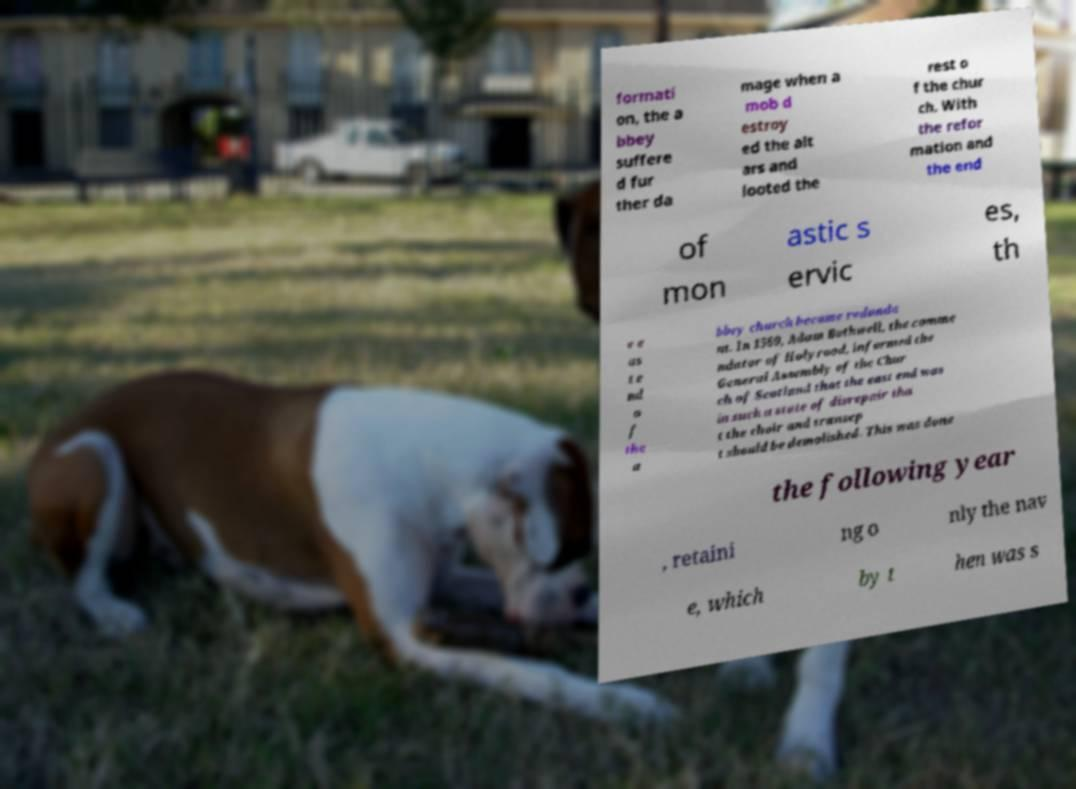Please read and relay the text visible in this image. What does it say? formati on, the a bbey suffere d fur ther da mage when a mob d estroy ed the alt ars and looted the rest o f the chur ch. With the refor mation and the end of mon astic s ervic es, th e e as t e nd o f the a bbey church became redunda nt. In 1569, Adam Bothwell, the comme ndator of Holyrood, informed the General Assembly of the Chur ch of Scotland that the east end was in such a state of disrepair tha t the choir and transep t should be demolished. This was done the following year , retaini ng o nly the nav e, which by t hen was s 